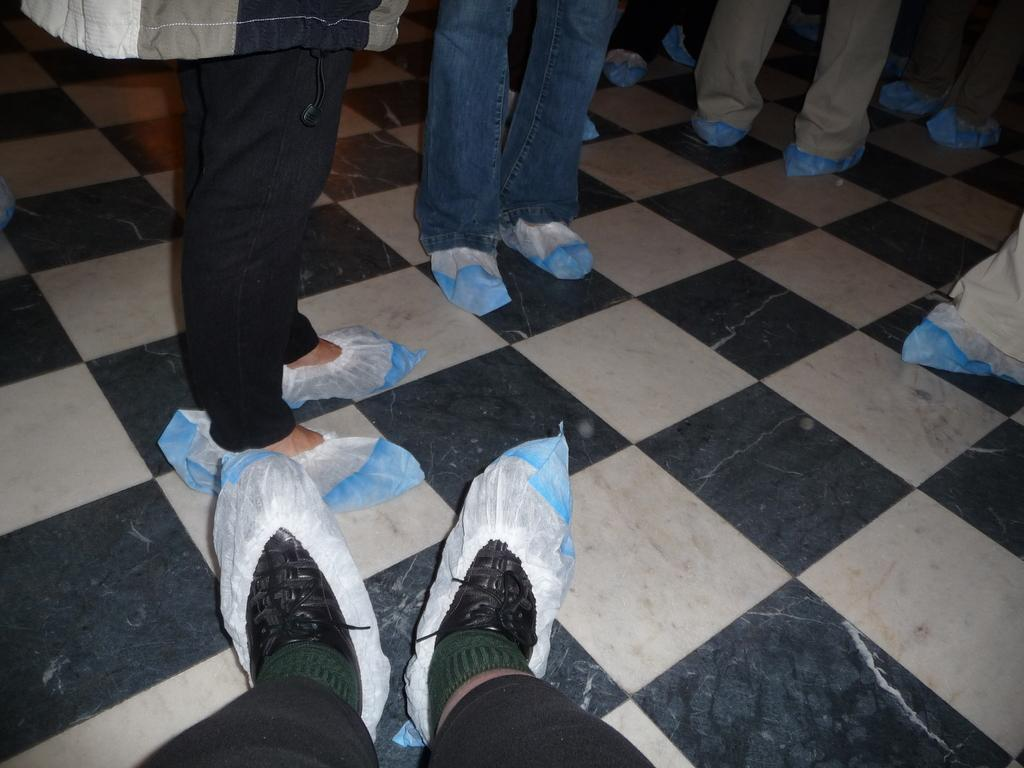What can be seen at the bottom of the image? The floor is visible in the image. What type of clothing are the persons wearing on their legs? The persons are wearing trousers. What type of bags can be seen in the image? There are plastic bags in the image. Can you describe the legs of the persons in the image? The legs of the persons are visible in the image. What other objects are present in the image besides the legs and plastic bags? There are other objects present in the image. What type of water is being used to write in the notebook in the image? There is no notebook or water present in the image. 